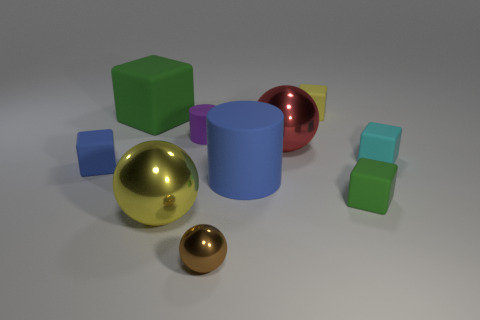Subtract all cyan cubes. How many cubes are left? 4 Subtract all yellow blocks. How many blocks are left? 4 Subtract all yellow blocks. Subtract all red spheres. How many blocks are left? 4 Subtract all cylinders. How many objects are left? 8 Add 6 large blue rubber cylinders. How many large blue rubber cylinders exist? 7 Subtract 0 yellow cylinders. How many objects are left? 10 Subtract all big blue things. Subtract all brown spheres. How many objects are left? 8 Add 2 tiny purple rubber things. How many tiny purple rubber things are left? 3 